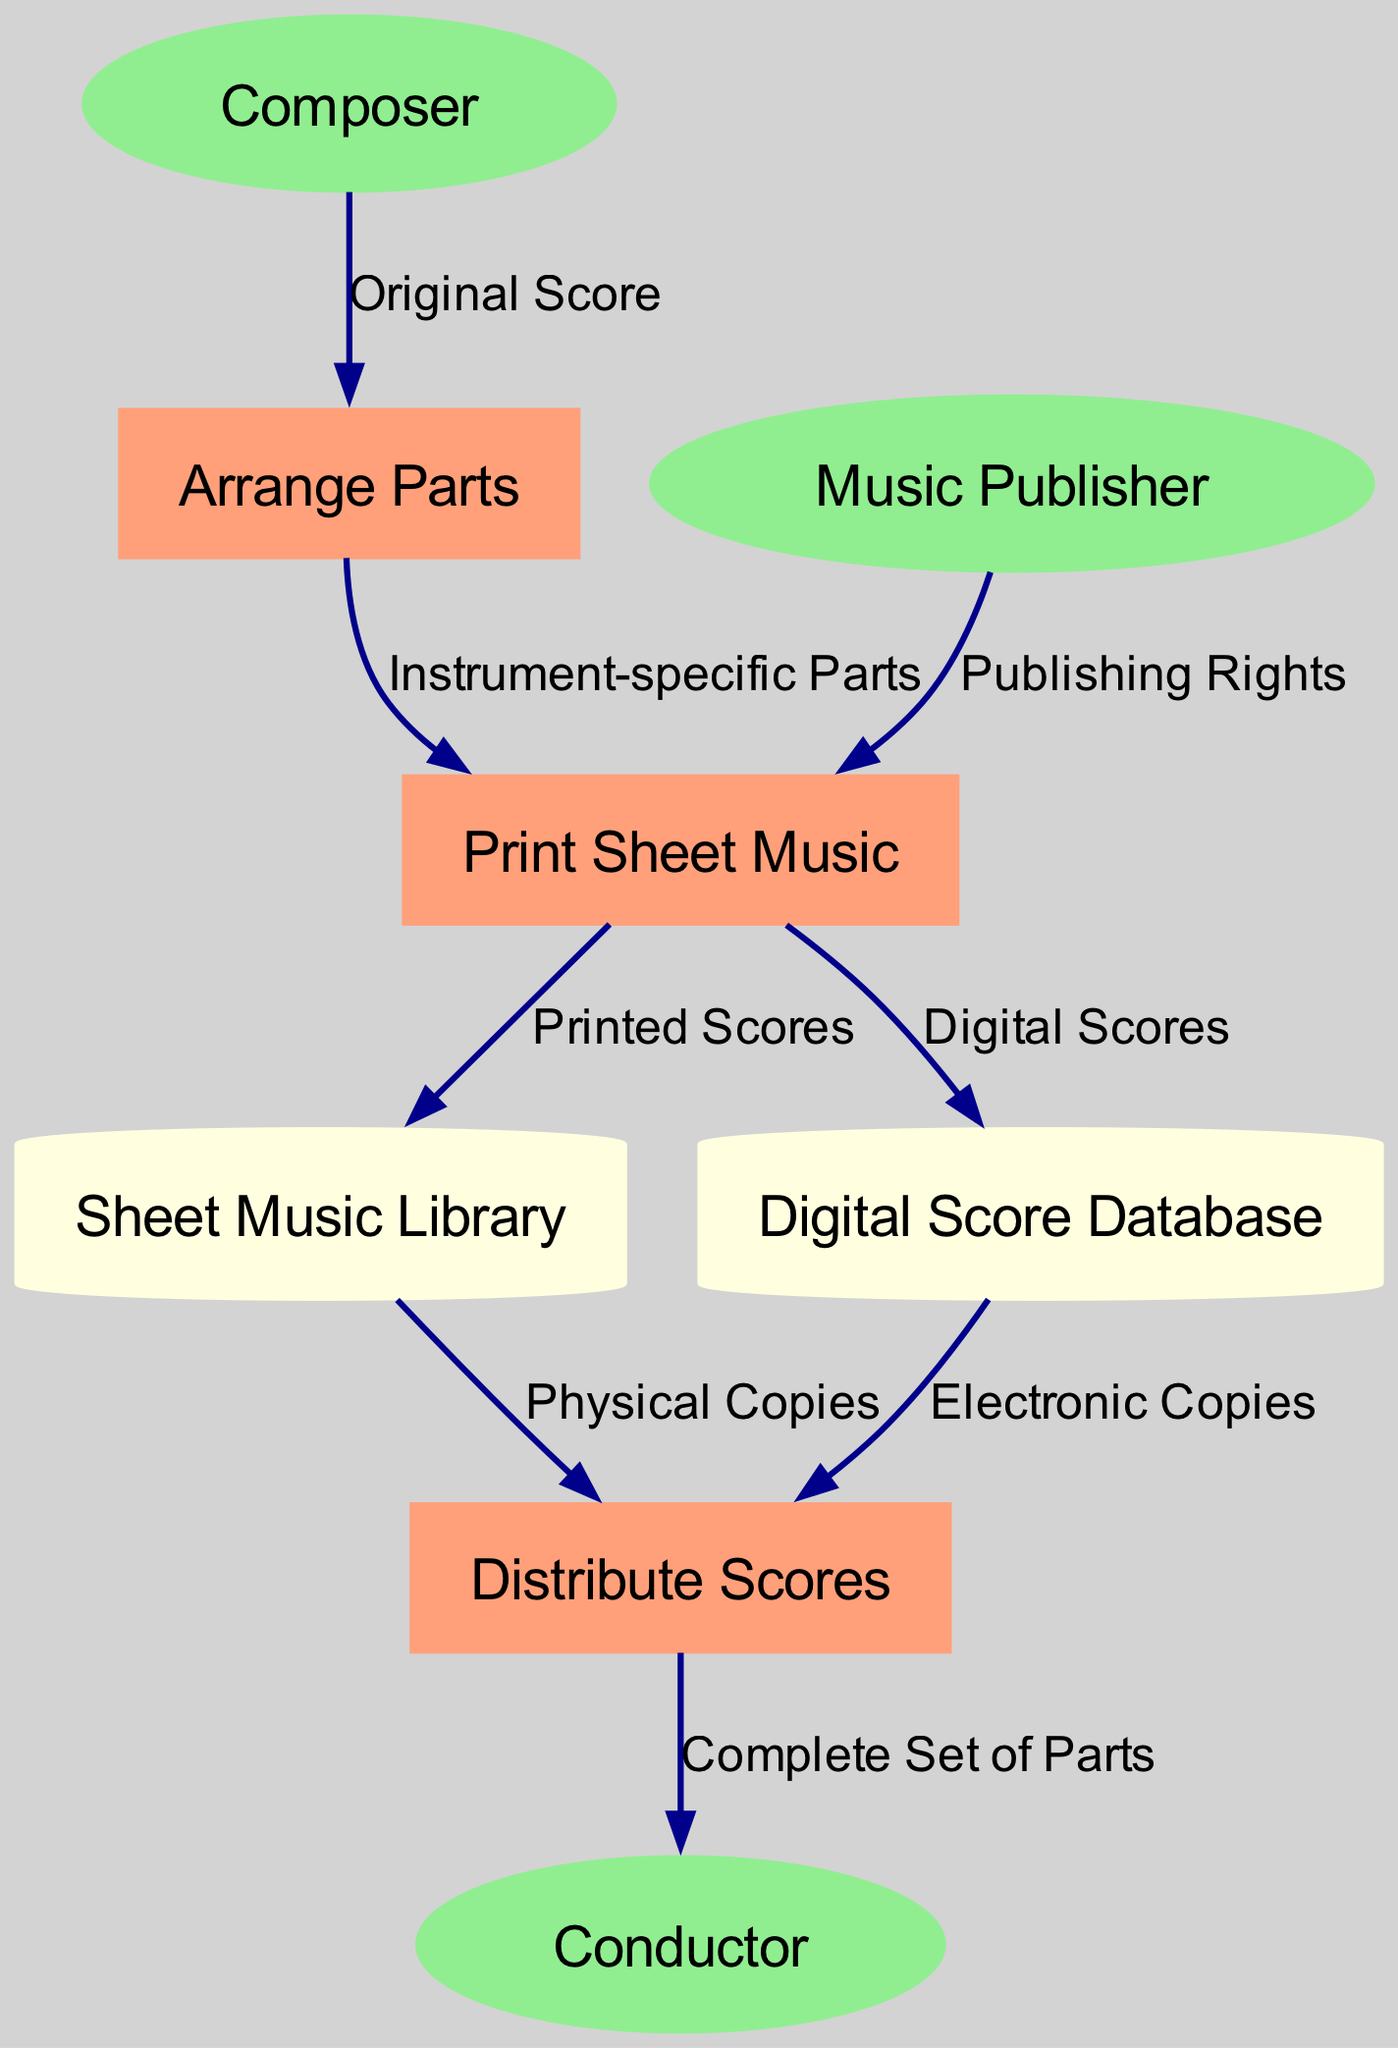What are the external entities in this diagram? The external entities are listed in the diagram. By reviewing the external entities section, we identify "Composer," "Music Publisher," and "Conductor" as the three entities involved.
Answer: Composer, Music Publisher, Conductor How many processes are represented in the diagram? The processes section of the diagram mentions three distinct processes: "Arrange Parts," "Print Sheet Music," and "Distribute Scores." Counting these gives us a total of three processes.
Answer: 3 What flows from the Composer to the process? The data flow originates from the "Composer" and goes to the "Arrange Parts" process. The label on this flow indicates it is the "Original Score."
Answer: Original Score Which data store receives the printed scores? The diagram shows an arrow from "Print Sheet Music" to the "Sheet Music Library." This demonstrates that the printed scores are directed to this data store.
Answer: Sheet Music Library What type of copies are distributed from the Digital Score Database? Looking at the data flow, we see that electronic copies are sent from the "Digital Score Database" to the "Distribute Scores" process, as indicated in the diagram.
Answer: Electronic Copies What is the final output that the Conductor receives? The "Distribute Scores" process outputs the "Complete Set of Parts" to the "Conductor." This is the final result for the Conductor after all prior processes.
Answer: Complete Set of Parts How many different types of parts are arranged in the process? The diagram shows that the process "Arrange Parts" specifically deals with "Instrument-specific Parts." This indicates that the arrangement is based on different instruments, suggesting that there are varying types of parts tailored to specific instruments.
Answer: Instrument-specific Parts What flow does the Music Publisher contribute to? The diagram indicates that the "Music Publisher" contributes "Publishing Rights" to the "Print Sheet Music" process. This flow demonstrates the involvement of the music publisher in the distribution process.
Answer: Publishing Rights Which data store is associated with printed scores? The printed scores from the "Print Sheet Music" process flow into the "Sheet Music Library," indicating this data store's role in housing physical copies of music.
Answer: Sheet Music Library 